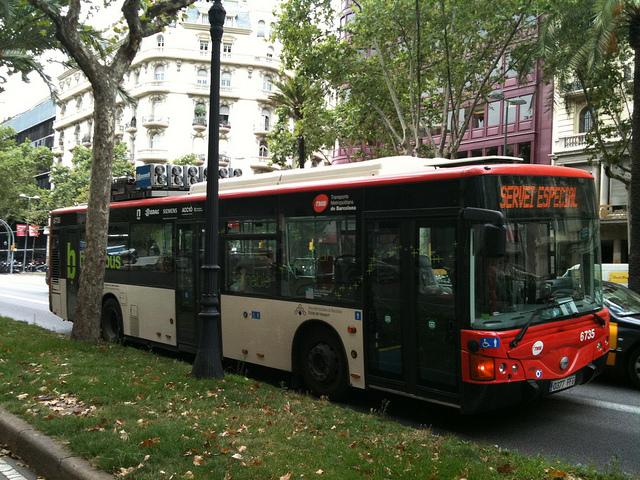How many people are on the bus?
Answer briefly. 0. What color is the bus?
Quick response, please. Red black white. Is this a summer scene?
Give a very brief answer. Yes. Is this a parking lot for buses?
Concise answer only. No. 